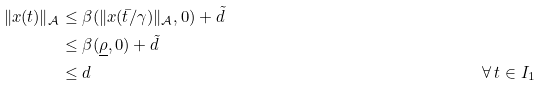Convert formula to latex. <formula><loc_0><loc_0><loc_500><loc_500>\| x ( t ) \| _ { \mathcal { A } } & \leq \beta ( \| x ( \bar { t } / \gamma ) \| _ { \mathcal { A } } , 0 ) + \tilde { d } \\ & \leq \beta ( \underline { \rho } , 0 ) + \tilde { d } \\ & \leq d & & \forall \, t \in I _ { 1 }</formula> 